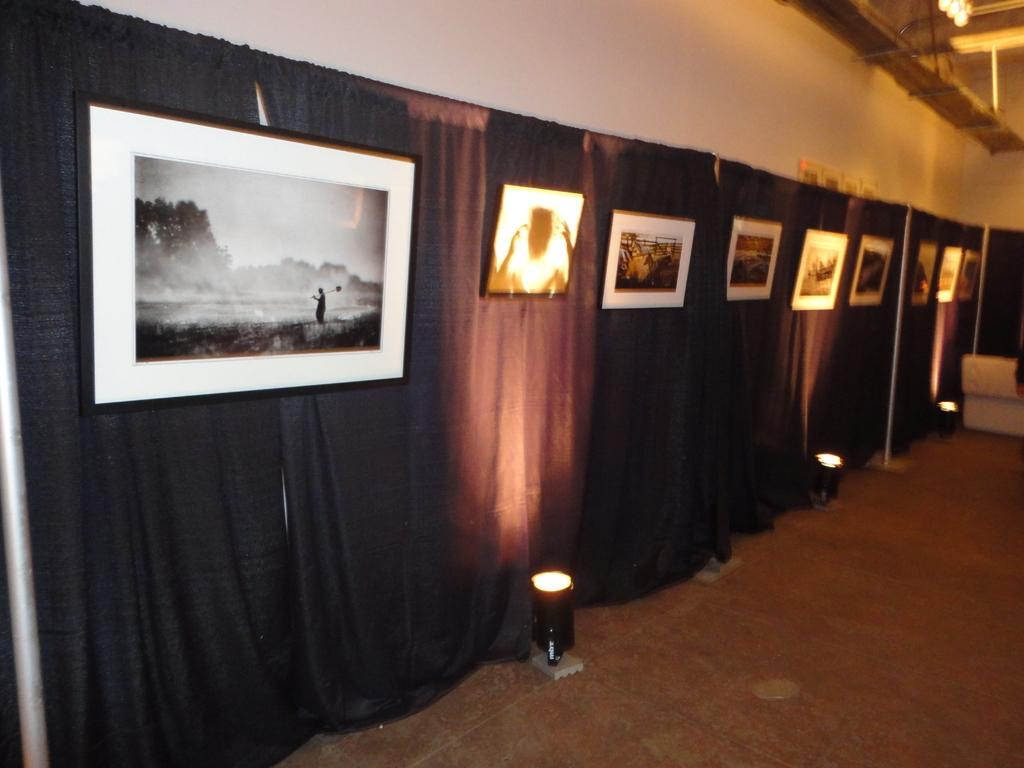What type of window treatment is visible in the image? There are curtains in the image. What can be used to provide illumination in the image? There are lights in the image. What is hanging on the wall in the image? There are frames on the wall in the image. What type of holiday is being celebrated in the image? There is no indication of a holiday being celebrated in the image. How many arms are visible in the image? There is no reference to arms or any human figures in the image. Is there an airplane visible in the image? No, there is no airplane present in the image. 